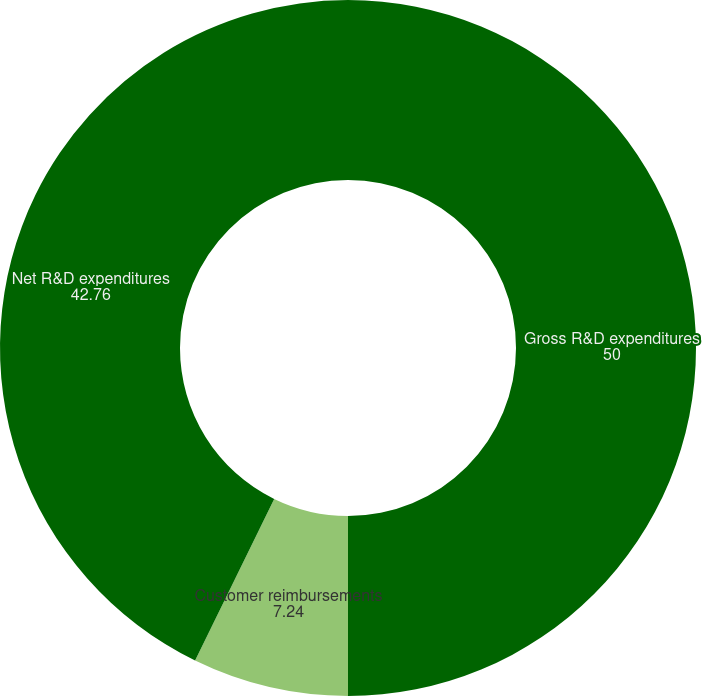Convert chart to OTSL. <chart><loc_0><loc_0><loc_500><loc_500><pie_chart><fcel>Gross R&D expenditures<fcel>Customer reimbursements<fcel>Net R&D expenditures<nl><fcel>50.0%<fcel>7.24%<fcel>42.76%<nl></chart> 